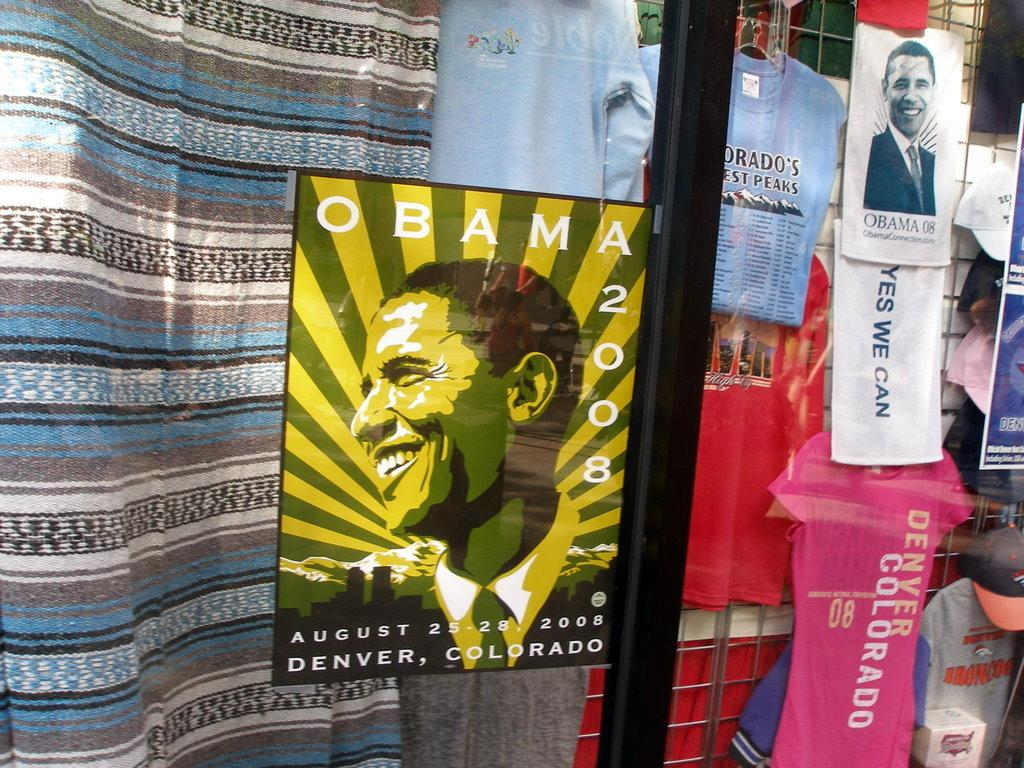Provide a one-sentence caption for the provided image. A storefront selling Obama 2008 commemorative memorabilia in poster, towel, and shirt form. 